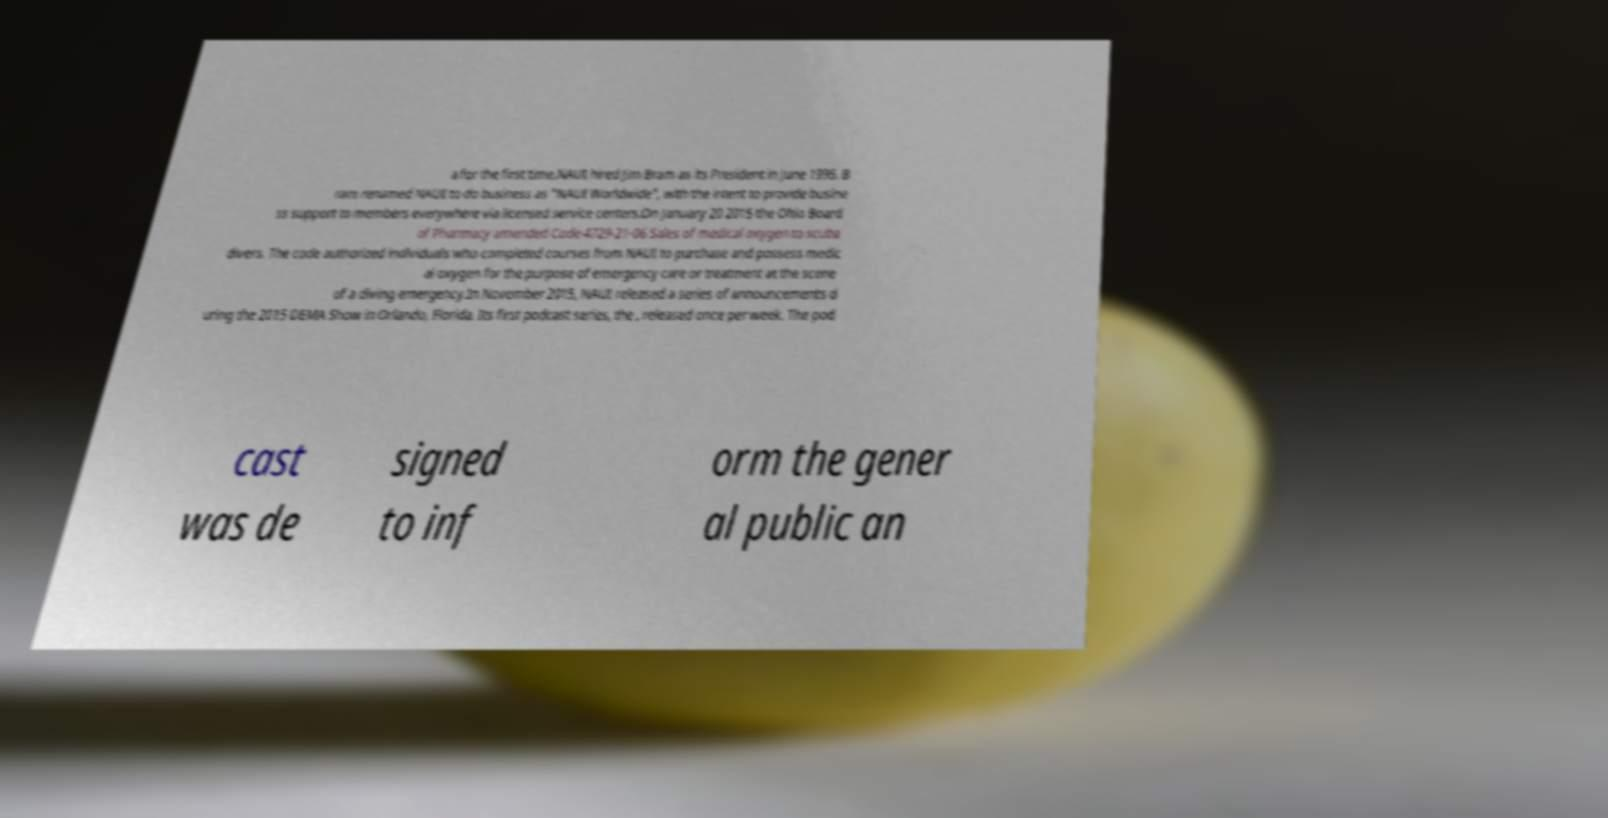Can you read and provide the text displayed in the image?This photo seems to have some interesting text. Can you extract and type it out for me? a for the first time.NAUI hired Jim Bram as its President in June 1995. B ram renamed NAUI to do business as "NAUI Worldwide", with the intent to provide busine ss support to members everywhere via licensed service centers.On January 20 2015 the Ohio Board of Pharmacy amended Code 4729-21-06 Sales of medical oxygen to scuba divers. The code authorized individuals who completed courses from NAUI to purchase and possess medic al oxygen for the purpose of emergency care or treatment at the scene of a diving emergency.In November 2015, NAUI released a series of announcements d uring the 2015 DEMA Show in Orlando, Florida. Its first podcast series, the , released once per week. The pod cast was de signed to inf orm the gener al public an 